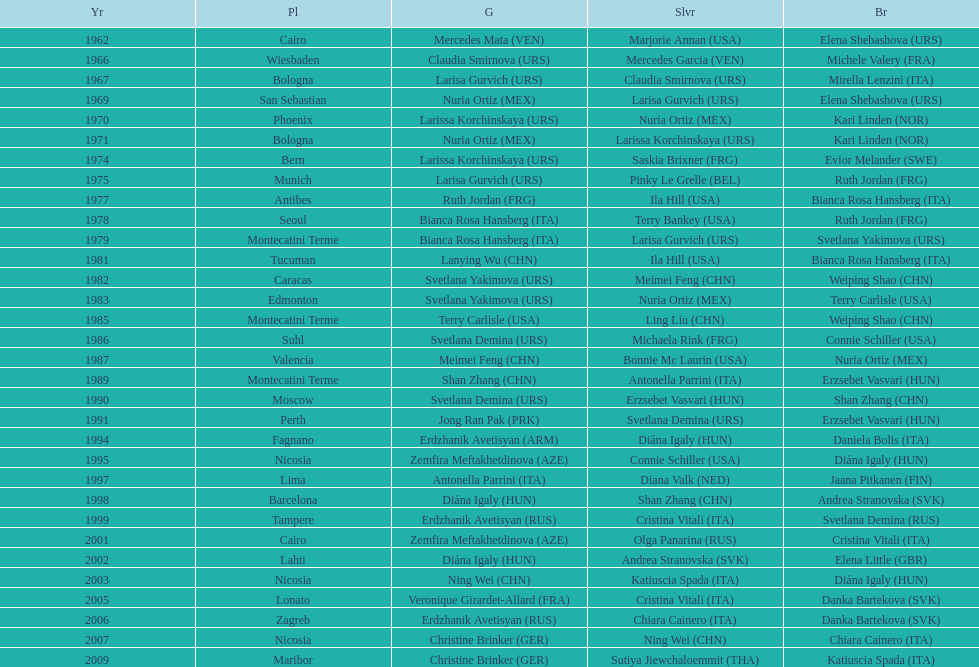Which country has the most bronze medals? Italy. 